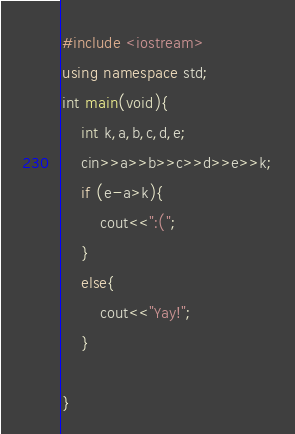Convert code to text. <code><loc_0><loc_0><loc_500><loc_500><_C++_>#include <iostream>
using namespace std;
int main(void){
    int k,a,b,c,d,e;
    cin>>a>>b>>c>>d>>e>>k;
    if (e-a>k){
        cout<<":(";
    }
    else{
        cout<<"Yay!";
    }
    
}
</code> 